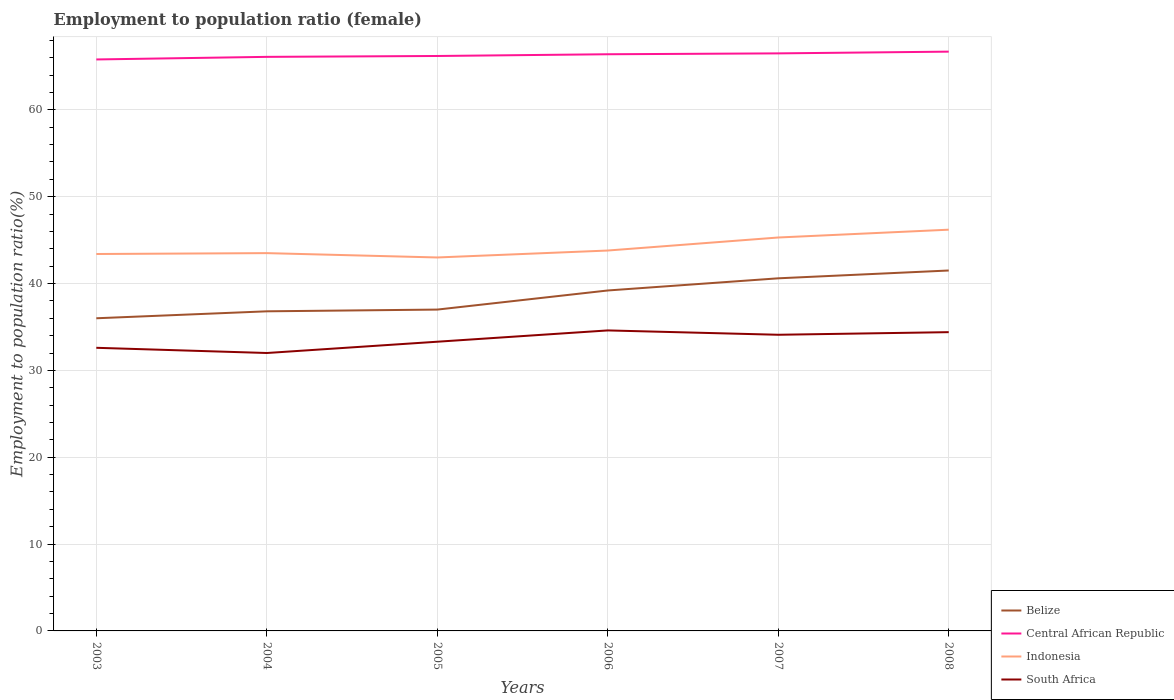How many different coloured lines are there?
Ensure brevity in your answer.  4. Is the number of lines equal to the number of legend labels?
Keep it short and to the point. Yes. Across all years, what is the maximum employment to population ratio in South Africa?
Your response must be concise. 32. In which year was the employment to population ratio in South Africa maximum?
Offer a very short reply. 2004. What is the total employment to population ratio in Belize in the graph?
Offer a very short reply. -1. Are the values on the major ticks of Y-axis written in scientific E-notation?
Provide a short and direct response. No. Does the graph contain any zero values?
Your response must be concise. No. Does the graph contain grids?
Provide a succinct answer. Yes. Where does the legend appear in the graph?
Ensure brevity in your answer.  Bottom right. How many legend labels are there?
Keep it short and to the point. 4. What is the title of the graph?
Your answer should be compact. Employment to population ratio (female). What is the Employment to population ratio(%) in Central African Republic in 2003?
Keep it short and to the point. 65.8. What is the Employment to population ratio(%) of Indonesia in 2003?
Make the answer very short. 43.4. What is the Employment to population ratio(%) in South Africa in 2003?
Give a very brief answer. 32.6. What is the Employment to population ratio(%) in Belize in 2004?
Give a very brief answer. 36.8. What is the Employment to population ratio(%) of Central African Republic in 2004?
Your response must be concise. 66.1. What is the Employment to population ratio(%) of Indonesia in 2004?
Give a very brief answer. 43.5. What is the Employment to population ratio(%) of Central African Republic in 2005?
Keep it short and to the point. 66.2. What is the Employment to population ratio(%) in Indonesia in 2005?
Ensure brevity in your answer.  43. What is the Employment to population ratio(%) of South Africa in 2005?
Ensure brevity in your answer.  33.3. What is the Employment to population ratio(%) of Belize in 2006?
Offer a very short reply. 39.2. What is the Employment to population ratio(%) of Central African Republic in 2006?
Keep it short and to the point. 66.4. What is the Employment to population ratio(%) in Indonesia in 2006?
Offer a very short reply. 43.8. What is the Employment to population ratio(%) in South Africa in 2006?
Make the answer very short. 34.6. What is the Employment to population ratio(%) of Belize in 2007?
Offer a terse response. 40.6. What is the Employment to population ratio(%) of Central African Republic in 2007?
Your answer should be very brief. 66.5. What is the Employment to population ratio(%) of Indonesia in 2007?
Give a very brief answer. 45.3. What is the Employment to population ratio(%) of South Africa in 2007?
Your response must be concise. 34.1. What is the Employment to population ratio(%) of Belize in 2008?
Ensure brevity in your answer.  41.5. What is the Employment to population ratio(%) of Central African Republic in 2008?
Provide a succinct answer. 66.7. What is the Employment to population ratio(%) of Indonesia in 2008?
Your response must be concise. 46.2. What is the Employment to population ratio(%) in South Africa in 2008?
Provide a short and direct response. 34.4. Across all years, what is the maximum Employment to population ratio(%) in Belize?
Provide a short and direct response. 41.5. Across all years, what is the maximum Employment to population ratio(%) in Central African Republic?
Make the answer very short. 66.7. Across all years, what is the maximum Employment to population ratio(%) of Indonesia?
Your response must be concise. 46.2. Across all years, what is the maximum Employment to population ratio(%) in South Africa?
Offer a very short reply. 34.6. Across all years, what is the minimum Employment to population ratio(%) of Belize?
Your answer should be very brief. 36. Across all years, what is the minimum Employment to population ratio(%) in Central African Republic?
Provide a short and direct response. 65.8. Across all years, what is the minimum Employment to population ratio(%) of Indonesia?
Provide a short and direct response. 43. What is the total Employment to population ratio(%) in Belize in the graph?
Give a very brief answer. 231.1. What is the total Employment to population ratio(%) in Central African Republic in the graph?
Your answer should be compact. 397.7. What is the total Employment to population ratio(%) of Indonesia in the graph?
Make the answer very short. 265.2. What is the total Employment to population ratio(%) of South Africa in the graph?
Your answer should be very brief. 201. What is the difference between the Employment to population ratio(%) of Belize in 2003 and that in 2004?
Offer a terse response. -0.8. What is the difference between the Employment to population ratio(%) of Indonesia in 2003 and that in 2004?
Your response must be concise. -0.1. What is the difference between the Employment to population ratio(%) in South Africa in 2003 and that in 2004?
Give a very brief answer. 0.6. What is the difference between the Employment to population ratio(%) in Belize in 2003 and that in 2005?
Provide a succinct answer. -1. What is the difference between the Employment to population ratio(%) in Central African Republic in 2003 and that in 2005?
Provide a short and direct response. -0.4. What is the difference between the Employment to population ratio(%) in Indonesia in 2003 and that in 2005?
Offer a terse response. 0.4. What is the difference between the Employment to population ratio(%) of Belize in 2003 and that in 2006?
Provide a short and direct response. -3.2. What is the difference between the Employment to population ratio(%) of Indonesia in 2003 and that in 2006?
Your response must be concise. -0.4. What is the difference between the Employment to population ratio(%) in Belize in 2003 and that in 2007?
Offer a terse response. -4.6. What is the difference between the Employment to population ratio(%) of Indonesia in 2003 and that in 2007?
Keep it short and to the point. -1.9. What is the difference between the Employment to population ratio(%) of South Africa in 2003 and that in 2008?
Ensure brevity in your answer.  -1.8. What is the difference between the Employment to population ratio(%) of Belize in 2004 and that in 2005?
Your answer should be compact. -0.2. What is the difference between the Employment to population ratio(%) in Indonesia in 2004 and that in 2005?
Offer a terse response. 0.5. What is the difference between the Employment to population ratio(%) in South Africa in 2004 and that in 2005?
Provide a succinct answer. -1.3. What is the difference between the Employment to population ratio(%) of Belize in 2004 and that in 2006?
Your response must be concise. -2.4. What is the difference between the Employment to population ratio(%) in Indonesia in 2004 and that in 2006?
Your answer should be compact. -0.3. What is the difference between the Employment to population ratio(%) in Belize in 2004 and that in 2008?
Your answer should be very brief. -4.7. What is the difference between the Employment to population ratio(%) in South Africa in 2004 and that in 2008?
Provide a short and direct response. -2.4. What is the difference between the Employment to population ratio(%) in Belize in 2005 and that in 2006?
Provide a succinct answer. -2.2. What is the difference between the Employment to population ratio(%) in Central African Republic in 2005 and that in 2006?
Your response must be concise. -0.2. What is the difference between the Employment to population ratio(%) in Indonesia in 2005 and that in 2006?
Your answer should be very brief. -0.8. What is the difference between the Employment to population ratio(%) in Indonesia in 2005 and that in 2007?
Offer a terse response. -2.3. What is the difference between the Employment to population ratio(%) of Belize in 2005 and that in 2008?
Your response must be concise. -4.5. What is the difference between the Employment to population ratio(%) of Indonesia in 2006 and that in 2007?
Your response must be concise. -1.5. What is the difference between the Employment to population ratio(%) in South Africa in 2006 and that in 2007?
Provide a short and direct response. 0.5. What is the difference between the Employment to population ratio(%) in Belize in 2006 and that in 2008?
Your response must be concise. -2.3. What is the difference between the Employment to population ratio(%) in Central African Republic in 2006 and that in 2008?
Make the answer very short. -0.3. What is the difference between the Employment to population ratio(%) in Indonesia in 2006 and that in 2008?
Your response must be concise. -2.4. What is the difference between the Employment to population ratio(%) in South Africa in 2006 and that in 2008?
Offer a very short reply. 0.2. What is the difference between the Employment to population ratio(%) in Belize in 2007 and that in 2008?
Your answer should be compact. -0.9. What is the difference between the Employment to population ratio(%) of Central African Republic in 2007 and that in 2008?
Ensure brevity in your answer.  -0.2. What is the difference between the Employment to population ratio(%) of South Africa in 2007 and that in 2008?
Your answer should be very brief. -0.3. What is the difference between the Employment to population ratio(%) in Belize in 2003 and the Employment to population ratio(%) in Central African Republic in 2004?
Your answer should be compact. -30.1. What is the difference between the Employment to population ratio(%) of Belize in 2003 and the Employment to population ratio(%) of Indonesia in 2004?
Offer a very short reply. -7.5. What is the difference between the Employment to population ratio(%) in Belize in 2003 and the Employment to population ratio(%) in South Africa in 2004?
Ensure brevity in your answer.  4. What is the difference between the Employment to population ratio(%) in Central African Republic in 2003 and the Employment to population ratio(%) in Indonesia in 2004?
Give a very brief answer. 22.3. What is the difference between the Employment to population ratio(%) in Central African Republic in 2003 and the Employment to population ratio(%) in South Africa in 2004?
Provide a short and direct response. 33.8. What is the difference between the Employment to population ratio(%) of Indonesia in 2003 and the Employment to population ratio(%) of South Africa in 2004?
Provide a short and direct response. 11.4. What is the difference between the Employment to population ratio(%) in Belize in 2003 and the Employment to population ratio(%) in Central African Republic in 2005?
Provide a succinct answer. -30.2. What is the difference between the Employment to population ratio(%) of Belize in 2003 and the Employment to population ratio(%) of Indonesia in 2005?
Offer a very short reply. -7. What is the difference between the Employment to population ratio(%) in Central African Republic in 2003 and the Employment to population ratio(%) in Indonesia in 2005?
Keep it short and to the point. 22.8. What is the difference between the Employment to population ratio(%) in Central African Republic in 2003 and the Employment to population ratio(%) in South Africa in 2005?
Offer a terse response. 32.5. What is the difference between the Employment to population ratio(%) of Belize in 2003 and the Employment to population ratio(%) of Central African Republic in 2006?
Keep it short and to the point. -30.4. What is the difference between the Employment to population ratio(%) of Central African Republic in 2003 and the Employment to population ratio(%) of Indonesia in 2006?
Your answer should be very brief. 22. What is the difference between the Employment to population ratio(%) of Central African Republic in 2003 and the Employment to population ratio(%) of South Africa in 2006?
Make the answer very short. 31.2. What is the difference between the Employment to population ratio(%) of Indonesia in 2003 and the Employment to population ratio(%) of South Africa in 2006?
Your answer should be compact. 8.8. What is the difference between the Employment to population ratio(%) in Belize in 2003 and the Employment to population ratio(%) in Central African Republic in 2007?
Your answer should be compact. -30.5. What is the difference between the Employment to population ratio(%) of Central African Republic in 2003 and the Employment to population ratio(%) of South Africa in 2007?
Offer a terse response. 31.7. What is the difference between the Employment to population ratio(%) in Indonesia in 2003 and the Employment to population ratio(%) in South Africa in 2007?
Your answer should be compact. 9.3. What is the difference between the Employment to population ratio(%) of Belize in 2003 and the Employment to population ratio(%) of Central African Republic in 2008?
Offer a terse response. -30.7. What is the difference between the Employment to population ratio(%) of Belize in 2003 and the Employment to population ratio(%) of Indonesia in 2008?
Make the answer very short. -10.2. What is the difference between the Employment to population ratio(%) of Belize in 2003 and the Employment to population ratio(%) of South Africa in 2008?
Your answer should be compact. 1.6. What is the difference between the Employment to population ratio(%) of Central African Republic in 2003 and the Employment to population ratio(%) of Indonesia in 2008?
Provide a succinct answer. 19.6. What is the difference between the Employment to population ratio(%) in Central African Republic in 2003 and the Employment to population ratio(%) in South Africa in 2008?
Offer a very short reply. 31.4. What is the difference between the Employment to population ratio(%) of Belize in 2004 and the Employment to population ratio(%) of Central African Republic in 2005?
Your answer should be compact. -29.4. What is the difference between the Employment to population ratio(%) in Belize in 2004 and the Employment to population ratio(%) in South Africa in 2005?
Ensure brevity in your answer.  3.5. What is the difference between the Employment to population ratio(%) in Central African Republic in 2004 and the Employment to population ratio(%) in Indonesia in 2005?
Offer a terse response. 23.1. What is the difference between the Employment to population ratio(%) of Central African Republic in 2004 and the Employment to population ratio(%) of South Africa in 2005?
Offer a very short reply. 32.8. What is the difference between the Employment to population ratio(%) in Indonesia in 2004 and the Employment to population ratio(%) in South Africa in 2005?
Keep it short and to the point. 10.2. What is the difference between the Employment to population ratio(%) in Belize in 2004 and the Employment to population ratio(%) in Central African Republic in 2006?
Keep it short and to the point. -29.6. What is the difference between the Employment to population ratio(%) of Central African Republic in 2004 and the Employment to population ratio(%) of Indonesia in 2006?
Provide a succinct answer. 22.3. What is the difference between the Employment to population ratio(%) of Central African Republic in 2004 and the Employment to population ratio(%) of South Africa in 2006?
Give a very brief answer. 31.5. What is the difference between the Employment to population ratio(%) in Indonesia in 2004 and the Employment to population ratio(%) in South Africa in 2006?
Your answer should be very brief. 8.9. What is the difference between the Employment to population ratio(%) of Belize in 2004 and the Employment to population ratio(%) of Central African Republic in 2007?
Keep it short and to the point. -29.7. What is the difference between the Employment to population ratio(%) in Belize in 2004 and the Employment to population ratio(%) in Indonesia in 2007?
Offer a terse response. -8.5. What is the difference between the Employment to population ratio(%) in Central African Republic in 2004 and the Employment to population ratio(%) in Indonesia in 2007?
Make the answer very short. 20.8. What is the difference between the Employment to population ratio(%) in Belize in 2004 and the Employment to population ratio(%) in Central African Republic in 2008?
Your answer should be very brief. -29.9. What is the difference between the Employment to population ratio(%) in Central African Republic in 2004 and the Employment to population ratio(%) in Indonesia in 2008?
Offer a terse response. 19.9. What is the difference between the Employment to population ratio(%) of Central African Republic in 2004 and the Employment to population ratio(%) of South Africa in 2008?
Give a very brief answer. 31.7. What is the difference between the Employment to population ratio(%) of Indonesia in 2004 and the Employment to population ratio(%) of South Africa in 2008?
Ensure brevity in your answer.  9.1. What is the difference between the Employment to population ratio(%) in Belize in 2005 and the Employment to population ratio(%) in Central African Republic in 2006?
Your answer should be very brief. -29.4. What is the difference between the Employment to population ratio(%) in Belize in 2005 and the Employment to population ratio(%) in Indonesia in 2006?
Keep it short and to the point. -6.8. What is the difference between the Employment to population ratio(%) of Belize in 2005 and the Employment to population ratio(%) of South Africa in 2006?
Offer a very short reply. 2.4. What is the difference between the Employment to population ratio(%) of Central African Republic in 2005 and the Employment to population ratio(%) of Indonesia in 2006?
Your answer should be compact. 22.4. What is the difference between the Employment to population ratio(%) in Central African Republic in 2005 and the Employment to population ratio(%) in South Africa in 2006?
Offer a very short reply. 31.6. What is the difference between the Employment to population ratio(%) of Indonesia in 2005 and the Employment to population ratio(%) of South Africa in 2006?
Make the answer very short. 8.4. What is the difference between the Employment to population ratio(%) in Belize in 2005 and the Employment to population ratio(%) in Central African Republic in 2007?
Your answer should be very brief. -29.5. What is the difference between the Employment to population ratio(%) of Belize in 2005 and the Employment to population ratio(%) of Indonesia in 2007?
Your answer should be very brief. -8.3. What is the difference between the Employment to population ratio(%) in Belize in 2005 and the Employment to population ratio(%) in South Africa in 2007?
Offer a terse response. 2.9. What is the difference between the Employment to population ratio(%) of Central African Republic in 2005 and the Employment to population ratio(%) of Indonesia in 2007?
Provide a succinct answer. 20.9. What is the difference between the Employment to population ratio(%) in Central African Republic in 2005 and the Employment to population ratio(%) in South Africa in 2007?
Keep it short and to the point. 32.1. What is the difference between the Employment to population ratio(%) in Indonesia in 2005 and the Employment to population ratio(%) in South Africa in 2007?
Offer a very short reply. 8.9. What is the difference between the Employment to population ratio(%) in Belize in 2005 and the Employment to population ratio(%) in Central African Republic in 2008?
Your answer should be very brief. -29.7. What is the difference between the Employment to population ratio(%) in Belize in 2005 and the Employment to population ratio(%) in Indonesia in 2008?
Ensure brevity in your answer.  -9.2. What is the difference between the Employment to population ratio(%) of Central African Republic in 2005 and the Employment to population ratio(%) of Indonesia in 2008?
Give a very brief answer. 20. What is the difference between the Employment to population ratio(%) in Central African Republic in 2005 and the Employment to population ratio(%) in South Africa in 2008?
Your answer should be compact. 31.8. What is the difference between the Employment to population ratio(%) in Indonesia in 2005 and the Employment to population ratio(%) in South Africa in 2008?
Your answer should be very brief. 8.6. What is the difference between the Employment to population ratio(%) of Belize in 2006 and the Employment to population ratio(%) of Central African Republic in 2007?
Offer a terse response. -27.3. What is the difference between the Employment to population ratio(%) of Belize in 2006 and the Employment to population ratio(%) of Indonesia in 2007?
Offer a terse response. -6.1. What is the difference between the Employment to population ratio(%) in Central African Republic in 2006 and the Employment to population ratio(%) in Indonesia in 2007?
Ensure brevity in your answer.  21.1. What is the difference between the Employment to population ratio(%) of Central African Republic in 2006 and the Employment to population ratio(%) of South Africa in 2007?
Offer a terse response. 32.3. What is the difference between the Employment to population ratio(%) of Belize in 2006 and the Employment to population ratio(%) of Central African Republic in 2008?
Offer a very short reply. -27.5. What is the difference between the Employment to population ratio(%) in Belize in 2006 and the Employment to population ratio(%) in South Africa in 2008?
Offer a terse response. 4.8. What is the difference between the Employment to population ratio(%) in Central African Republic in 2006 and the Employment to population ratio(%) in Indonesia in 2008?
Offer a very short reply. 20.2. What is the difference between the Employment to population ratio(%) of Indonesia in 2006 and the Employment to population ratio(%) of South Africa in 2008?
Ensure brevity in your answer.  9.4. What is the difference between the Employment to population ratio(%) in Belize in 2007 and the Employment to population ratio(%) in Central African Republic in 2008?
Provide a short and direct response. -26.1. What is the difference between the Employment to population ratio(%) in Belize in 2007 and the Employment to population ratio(%) in Indonesia in 2008?
Offer a terse response. -5.6. What is the difference between the Employment to population ratio(%) of Belize in 2007 and the Employment to population ratio(%) of South Africa in 2008?
Your response must be concise. 6.2. What is the difference between the Employment to population ratio(%) of Central African Republic in 2007 and the Employment to population ratio(%) of Indonesia in 2008?
Provide a succinct answer. 20.3. What is the difference between the Employment to population ratio(%) of Central African Republic in 2007 and the Employment to population ratio(%) of South Africa in 2008?
Offer a terse response. 32.1. What is the average Employment to population ratio(%) of Belize per year?
Make the answer very short. 38.52. What is the average Employment to population ratio(%) of Central African Republic per year?
Your response must be concise. 66.28. What is the average Employment to population ratio(%) in Indonesia per year?
Your answer should be compact. 44.2. What is the average Employment to population ratio(%) in South Africa per year?
Ensure brevity in your answer.  33.5. In the year 2003, what is the difference between the Employment to population ratio(%) of Belize and Employment to population ratio(%) of Central African Republic?
Give a very brief answer. -29.8. In the year 2003, what is the difference between the Employment to population ratio(%) of Belize and Employment to population ratio(%) of Indonesia?
Provide a short and direct response. -7.4. In the year 2003, what is the difference between the Employment to population ratio(%) of Central African Republic and Employment to population ratio(%) of Indonesia?
Ensure brevity in your answer.  22.4. In the year 2003, what is the difference between the Employment to population ratio(%) of Central African Republic and Employment to population ratio(%) of South Africa?
Provide a succinct answer. 33.2. In the year 2004, what is the difference between the Employment to population ratio(%) of Belize and Employment to population ratio(%) of Central African Republic?
Your answer should be compact. -29.3. In the year 2004, what is the difference between the Employment to population ratio(%) in Belize and Employment to population ratio(%) in South Africa?
Provide a short and direct response. 4.8. In the year 2004, what is the difference between the Employment to population ratio(%) of Central African Republic and Employment to population ratio(%) of Indonesia?
Offer a terse response. 22.6. In the year 2004, what is the difference between the Employment to population ratio(%) in Central African Republic and Employment to population ratio(%) in South Africa?
Give a very brief answer. 34.1. In the year 2005, what is the difference between the Employment to population ratio(%) in Belize and Employment to population ratio(%) in Central African Republic?
Provide a short and direct response. -29.2. In the year 2005, what is the difference between the Employment to population ratio(%) in Belize and Employment to population ratio(%) in Indonesia?
Give a very brief answer. -6. In the year 2005, what is the difference between the Employment to population ratio(%) in Central African Republic and Employment to population ratio(%) in Indonesia?
Ensure brevity in your answer.  23.2. In the year 2005, what is the difference between the Employment to population ratio(%) of Central African Republic and Employment to population ratio(%) of South Africa?
Provide a short and direct response. 32.9. In the year 2006, what is the difference between the Employment to population ratio(%) of Belize and Employment to population ratio(%) of Central African Republic?
Your answer should be compact. -27.2. In the year 2006, what is the difference between the Employment to population ratio(%) in Belize and Employment to population ratio(%) in South Africa?
Offer a terse response. 4.6. In the year 2006, what is the difference between the Employment to population ratio(%) in Central African Republic and Employment to population ratio(%) in Indonesia?
Provide a short and direct response. 22.6. In the year 2006, what is the difference between the Employment to population ratio(%) in Central African Republic and Employment to population ratio(%) in South Africa?
Provide a short and direct response. 31.8. In the year 2007, what is the difference between the Employment to population ratio(%) of Belize and Employment to population ratio(%) of Central African Republic?
Ensure brevity in your answer.  -25.9. In the year 2007, what is the difference between the Employment to population ratio(%) of Belize and Employment to population ratio(%) of Indonesia?
Provide a succinct answer. -4.7. In the year 2007, what is the difference between the Employment to population ratio(%) of Belize and Employment to population ratio(%) of South Africa?
Provide a short and direct response. 6.5. In the year 2007, what is the difference between the Employment to population ratio(%) in Central African Republic and Employment to population ratio(%) in Indonesia?
Offer a very short reply. 21.2. In the year 2007, what is the difference between the Employment to population ratio(%) of Central African Republic and Employment to population ratio(%) of South Africa?
Your answer should be compact. 32.4. In the year 2007, what is the difference between the Employment to population ratio(%) of Indonesia and Employment to population ratio(%) of South Africa?
Provide a short and direct response. 11.2. In the year 2008, what is the difference between the Employment to population ratio(%) in Belize and Employment to population ratio(%) in Central African Republic?
Ensure brevity in your answer.  -25.2. In the year 2008, what is the difference between the Employment to population ratio(%) of Belize and Employment to population ratio(%) of South Africa?
Your response must be concise. 7.1. In the year 2008, what is the difference between the Employment to population ratio(%) of Central African Republic and Employment to population ratio(%) of South Africa?
Your answer should be very brief. 32.3. What is the ratio of the Employment to population ratio(%) in Belize in 2003 to that in 2004?
Ensure brevity in your answer.  0.98. What is the ratio of the Employment to population ratio(%) of Central African Republic in 2003 to that in 2004?
Offer a very short reply. 1. What is the ratio of the Employment to population ratio(%) in Indonesia in 2003 to that in 2004?
Provide a short and direct response. 1. What is the ratio of the Employment to population ratio(%) of South Africa in 2003 to that in 2004?
Your answer should be compact. 1.02. What is the ratio of the Employment to population ratio(%) in Belize in 2003 to that in 2005?
Provide a succinct answer. 0.97. What is the ratio of the Employment to population ratio(%) of Indonesia in 2003 to that in 2005?
Your answer should be compact. 1.01. What is the ratio of the Employment to population ratio(%) of Belize in 2003 to that in 2006?
Ensure brevity in your answer.  0.92. What is the ratio of the Employment to population ratio(%) of Central African Republic in 2003 to that in 2006?
Provide a succinct answer. 0.99. What is the ratio of the Employment to population ratio(%) in Indonesia in 2003 to that in 2006?
Provide a succinct answer. 0.99. What is the ratio of the Employment to population ratio(%) of South Africa in 2003 to that in 2006?
Your answer should be compact. 0.94. What is the ratio of the Employment to population ratio(%) of Belize in 2003 to that in 2007?
Ensure brevity in your answer.  0.89. What is the ratio of the Employment to population ratio(%) of Indonesia in 2003 to that in 2007?
Offer a very short reply. 0.96. What is the ratio of the Employment to population ratio(%) of South Africa in 2003 to that in 2007?
Give a very brief answer. 0.96. What is the ratio of the Employment to population ratio(%) of Belize in 2003 to that in 2008?
Your answer should be compact. 0.87. What is the ratio of the Employment to population ratio(%) of Central African Republic in 2003 to that in 2008?
Make the answer very short. 0.99. What is the ratio of the Employment to population ratio(%) in Indonesia in 2003 to that in 2008?
Your answer should be compact. 0.94. What is the ratio of the Employment to population ratio(%) of South Africa in 2003 to that in 2008?
Make the answer very short. 0.95. What is the ratio of the Employment to population ratio(%) in Central African Republic in 2004 to that in 2005?
Your response must be concise. 1. What is the ratio of the Employment to population ratio(%) in Indonesia in 2004 to that in 2005?
Provide a short and direct response. 1.01. What is the ratio of the Employment to population ratio(%) in Belize in 2004 to that in 2006?
Provide a succinct answer. 0.94. What is the ratio of the Employment to population ratio(%) of Central African Republic in 2004 to that in 2006?
Keep it short and to the point. 1. What is the ratio of the Employment to population ratio(%) in Indonesia in 2004 to that in 2006?
Make the answer very short. 0.99. What is the ratio of the Employment to population ratio(%) in South Africa in 2004 to that in 2006?
Offer a very short reply. 0.92. What is the ratio of the Employment to population ratio(%) in Belize in 2004 to that in 2007?
Make the answer very short. 0.91. What is the ratio of the Employment to population ratio(%) of Central African Republic in 2004 to that in 2007?
Give a very brief answer. 0.99. What is the ratio of the Employment to population ratio(%) of Indonesia in 2004 to that in 2007?
Your answer should be compact. 0.96. What is the ratio of the Employment to population ratio(%) in South Africa in 2004 to that in 2007?
Your answer should be compact. 0.94. What is the ratio of the Employment to population ratio(%) of Belize in 2004 to that in 2008?
Provide a succinct answer. 0.89. What is the ratio of the Employment to population ratio(%) of Central African Republic in 2004 to that in 2008?
Offer a very short reply. 0.99. What is the ratio of the Employment to population ratio(%) in Indonesia in 2004 to that in 2008?
Provide a short and direct response. 0.94. What is the ratio of the Employment to population ratio(%) of South Africa in 2004 to that in 2008?
Ensure brevity in your answer.  0.93. What is the ratio of the Employment to population ratio(%) of Belize in 2005 to that in 2006?
Provide a short and direct response. 0.94. What is the ratio of the Employment to population ratio(%) of Central African Republic in 2005 to that in 2006?
Your answer should be very brief. 1. What is the ratio of the Employment to population ratio(%) in Indonesia in 2005 to that in 2006?
Your answer should be compact. 0.98. What is the ratio of the Employment to population ratio(%) of South Africa in 2005 to that in 2006?
Your answer should be very brief. 0.96. What is the ratio of the Employment to population ratio(%) in Belize in 2005 to that in 2007?
Make the answer very short. 0.91. What is the ratio of the Employment to population ratio(%) in Central African Republic in 2005 to that in 2007?
Offer a very short reply. 1. What is the ratio of the Employment to population ratio(%) of Indonesia in 2005 to that in 2007?
Ensure brevity in your answer.  0.95. What is the ratio of the Employment to population ratio(%) in South Africa in 2005 to that in 2007?
Your answer should be very brief. 0.98. What is the ratio of the Employment to population ratio(%) in Belize in 2005 to that in 2008?
Make the answer very short. 0.89. What is the ratio of the Employment to population ratio(%) of Central African Republic in 2005 to that in 2008?
Your answer should be compact. 0.99. What is the ratio of the Employment to population ratio(%) of Indonesia in 2005 to that in 2008?
Offer a terse response. 0.93. What is the ratio of the Employment to population ratio(%) of South Africa in 2005 to that in 2008?
Ensure brevity in your answer.  0.97. What is the ratio of the Employment to population ratio(%) in Belize in 2006 to that in 2007?
Offer a terse response. 0.97. What is the ratio of the Employment to population ratio(%) in Indonesia in 2006 to that in 2007?
Provide a short and direct response. 0.97. What is the ratio of the Employment to population ratio(%) in South Africa in 2006 to that in 2007?
Offer a very short reply. 1.01. What is the ratio of the Employment to population ratio(%) in Belize in 2006 to that in 2008?
Ensure brevity in your answer.  0.94. What is the ratio of the Employment to population ratio(%) of Central African Republic in 2006 to that in 2008?
Your answer should be compact. 1. What is the ratio of the Employment to population ratio(%) of Indonesia in 2006 to that in 2008?
Provide a short and direct response. 0.95. What is the ratio of the Employment to population ratio(%) of Belize in 2007 to that in 2008?
Make the answer very short. 0.98. What is the ratio of the Employment to population ratio(%) of Central African Republic in 2007 to that in 2008?
Your response must be concise. 1. What is the ratio of the Employment to population ratio(%) of Indonesia in 2007 to that in 2008?
Ensure brevity in your answer.  0.98. What is the ratio of the Employment to population ratio(%) of South Africa in 2007 to that in 2008?
Your answer should be very brief. 0.99. What is the difference between the highest and the second highest Employment to population ratio(%) of Belize?
Your answer should be very brief. 0.9. What is the difference between the highest and the lowest Employment to population ratio(%) in Central African Republic?
Ensure brevity in your answer.  0.9. What is the difference between the highest and the lowest Employment to population ratio(%) of Indonesia?
Your answer should be compact. 3.2. What is the difference between the highest and the lowest Employment to population ratio(%) of South Africa?
Provide a short and direct response. 2.6. 